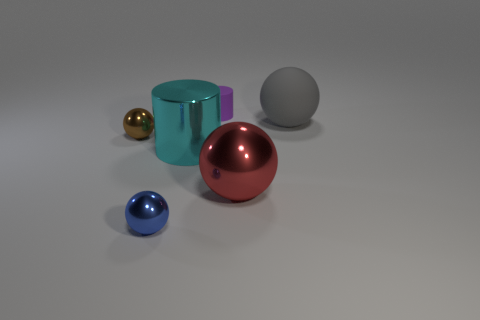What number of things are purple rubber things or cylinders that are behind the metal cylinder?
Ensure brevity in your answer.  1. There is a large ball that is the same material as the small blue thing; what color is it?
Ensure brevity in your answer.  Red. What number of blue objects are the same material as the red object?
Your answer should be compact. 1. How many small gray rubber things are there?
Offer a very short reply. 0. There is a large ball that is in front of the brown metal object; is its color the same as the small sphere behind the red sphere?
Keep it short and to the point. No. There is a small brown shiny object; how many purple cylinders are on the left side of it?
Offer a terse response. 0. Is there another red object of the same shape as the small matte object?
Give a very brief answer. No. Is the large thing left of the purple object made of the same material as the tiny thing that is to the right of the small blue shiny object?
Make the answer very short. No. What is the size of the shiny ball that is behind the cylinder that is in front of the matte thing left of the big red metallic thing?
Provide a succinct answer. Small. There is a red sphere that is the same size as the gray matte ball; what material is it?
Your answer should be very brief. Metal. 